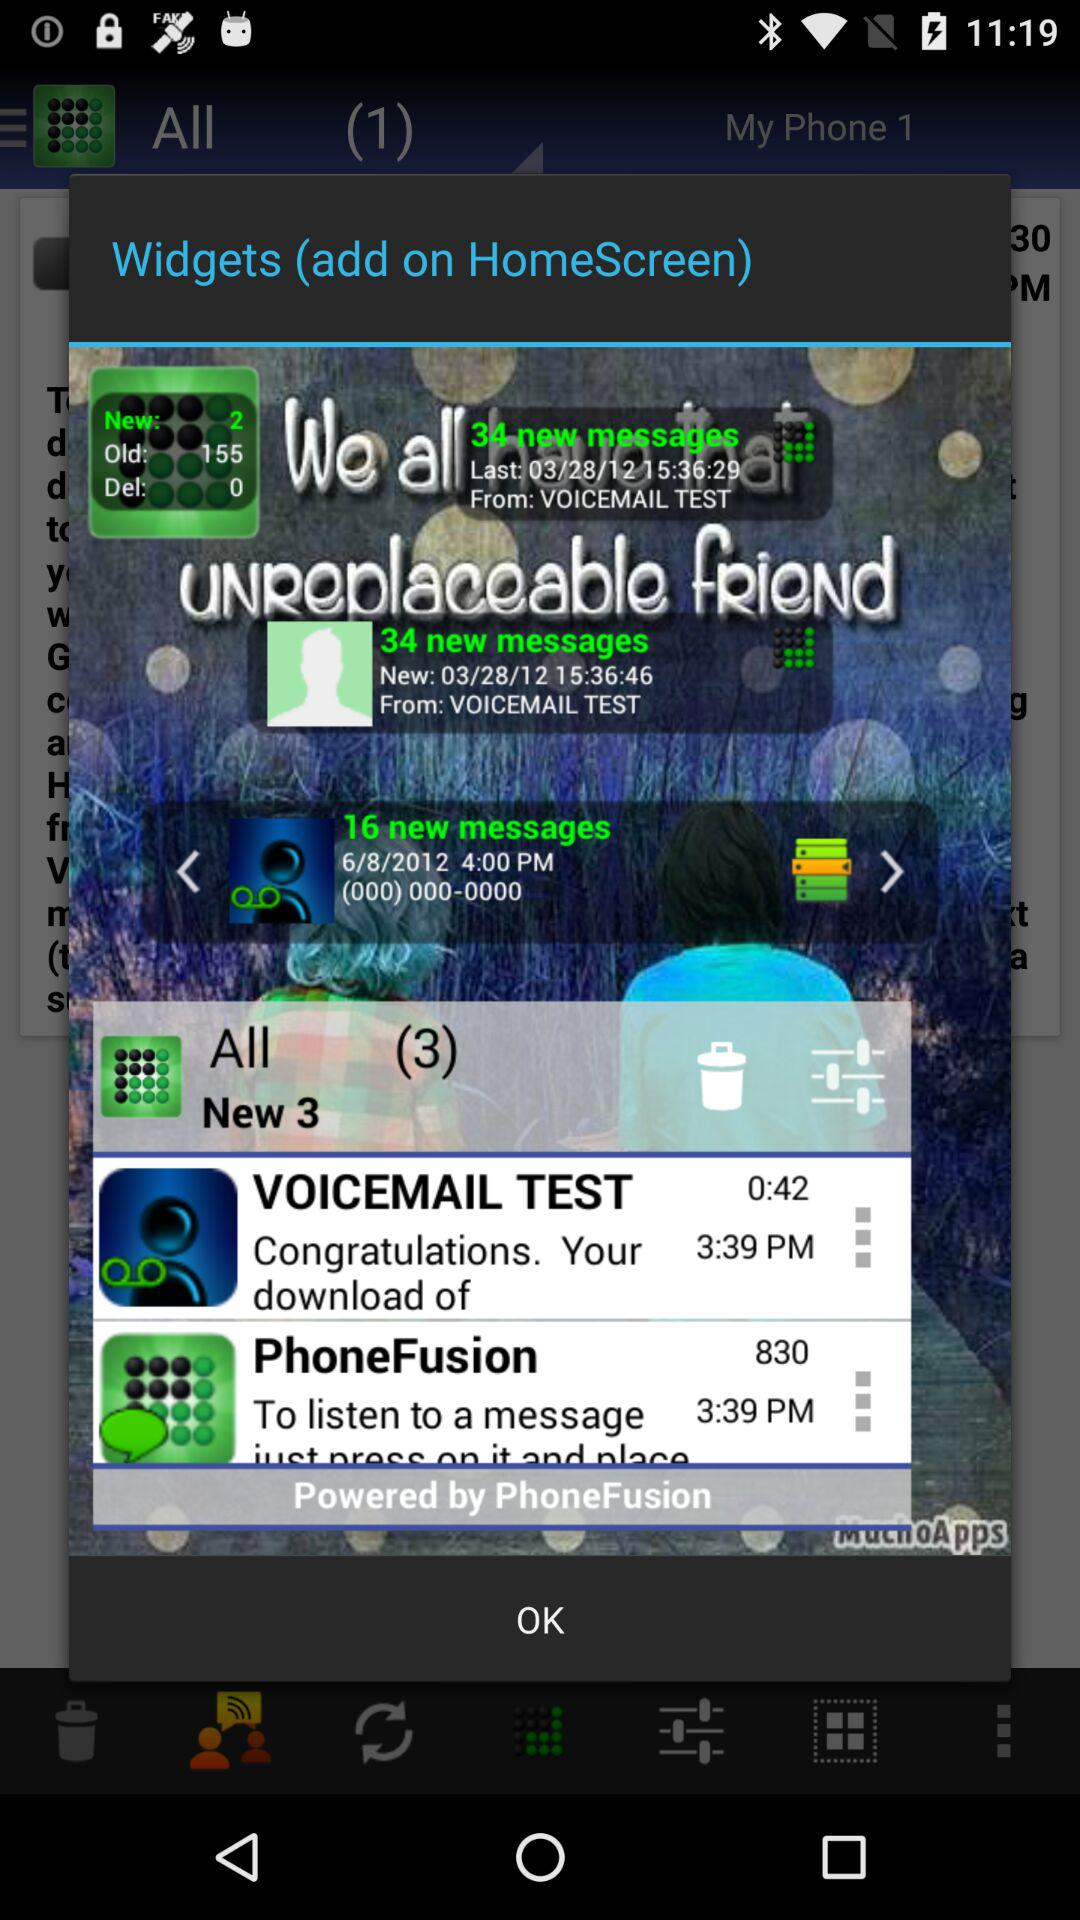At what time did we get the message from "VOICEMAIL TEST"? You got the message from "VOICEMAIL TEST" at 3:39 p.m. 